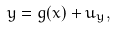Convert formula to latex. <formula><loc_0><loc_0><loc_500><loc_500>y = g ( x ) + u _ { y } ,</formula> 